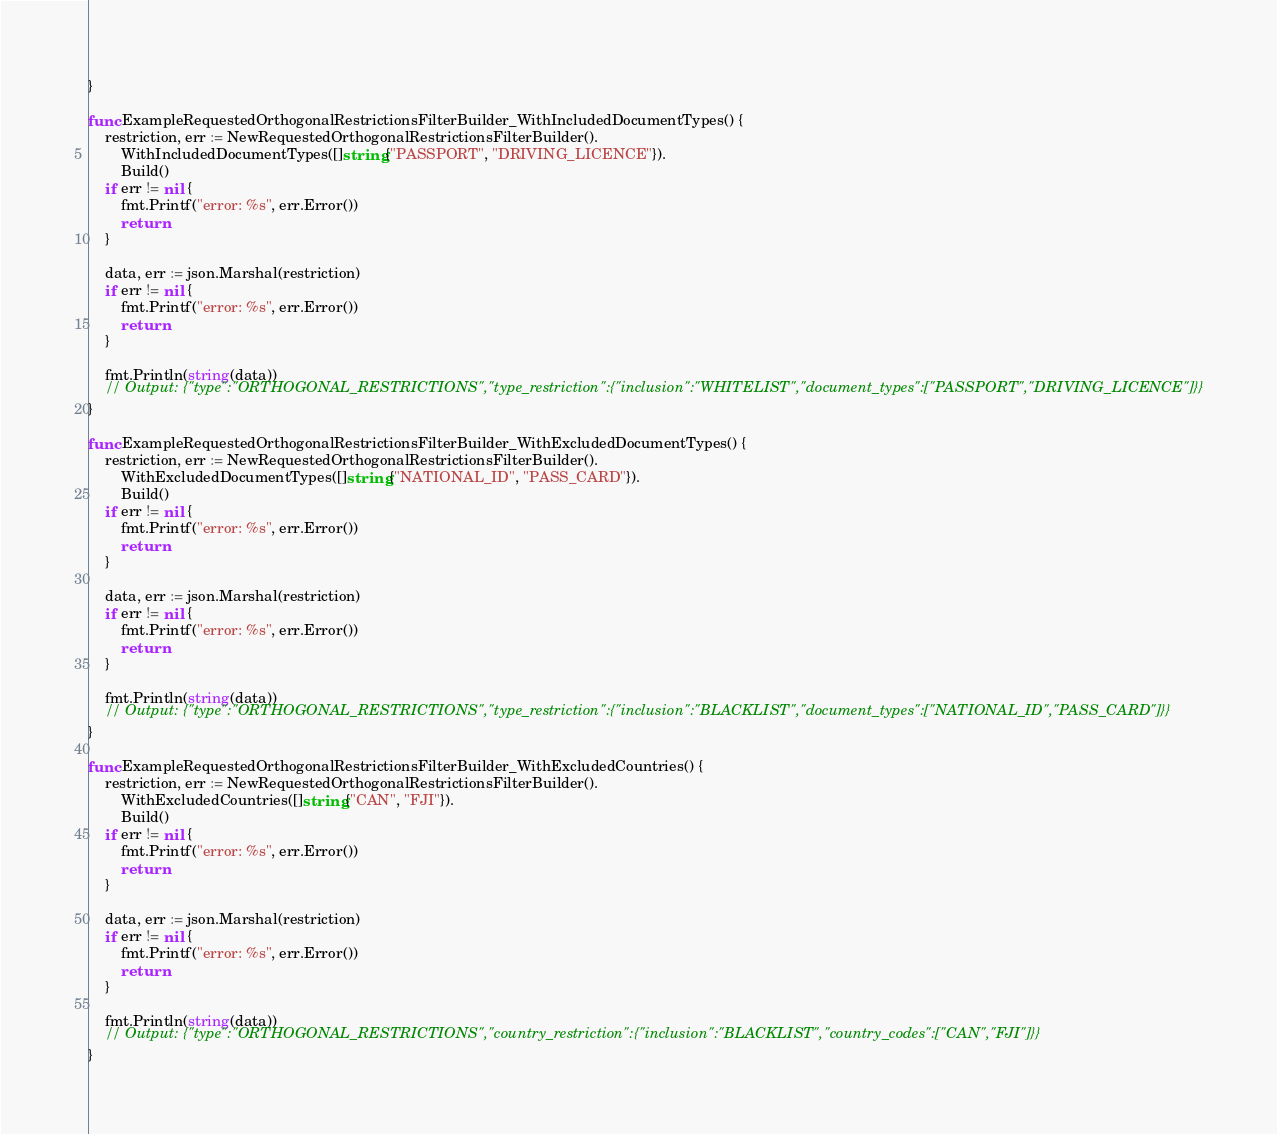Convert code to text. <code><loc_0><loc_0><loc_500><loc_500><_Go_>}

func ExampleRequestedOrthogonalRestrictionsFilterBuilder_WithIncludedDocumentTypes() {
	restriction, err := NewRequestedOrthogonalRestrictionsFilterBuilder().
		WithIncludedDocumentTypes([]string{"PASSPORT", "DRIVING_LICENCE"}).
		Build()
	if err != nil {
		fmt.Printf("error: %s", err.Error())
		return
	}

	data, err := json.Marshal(restriction)
	if err != nil {
		fmt.Printf("error: %s", err.Error())
		return
	}

	fmt.Println(string(data))
	// Output: {"type":"ORTHOGONAL_RESTRICTIONS","type_restriction":{"inclusion":"WHITELIST","document_types":["PASSPORT","DRIVING_LICENCE"]}}
}

func ExampleRequestedOrthogonalRestrictionsFilterBuilder_WithExcludedDocumentTypes() {
	restriction, err := NewRequestedOrthogonalRestrictionsFilterBuilder().
		WithExcludedDocumentTypes([]string{"NATIONAL_ID", "PASS_CARD"}).
		Build()
	if err != nil {
		fmt.Printf("error: %s", err.Error())
		return
	}

	data, err := json.Marshal(restriction)
	if err != nil {
		fmt.Printf("error: %s", err.Error())
		return
	}

	fmt.Println(string(data))
	// Output: {"type":"ORTHOGONAL_RESTRICTIONS","type_restriction":{"inclusion":"BLACKLIST","document_types":["NATIONAL_ID","PASS_CARD"]}}
}

func ExampleRequestedOrthogonalRestrictionsFilterBuilder_WithExcludedCountries() {
	restriction, err := NewRequestedOrthogonalRestrictionsFilterBuilder().
		WithExcludedCountries([]string{"CAN", "FJI"}).
		Build()
	if err != nil {
		fmt.Printf("error: %s", err.Error())
		return
	}

	data, err := json.Marshal(restriction)
	if err != nil {
		fmt.Printf("error: %s", err.Error())
		return
	}

	fmt.Println(string(data))
	// Output: {"type":"ORTHOGONAL_RESTRICTIONS","country_restriction":{"inclusion":"BLACKLIST","country_codes":["CAN","FJI"]}}
}
</code> 